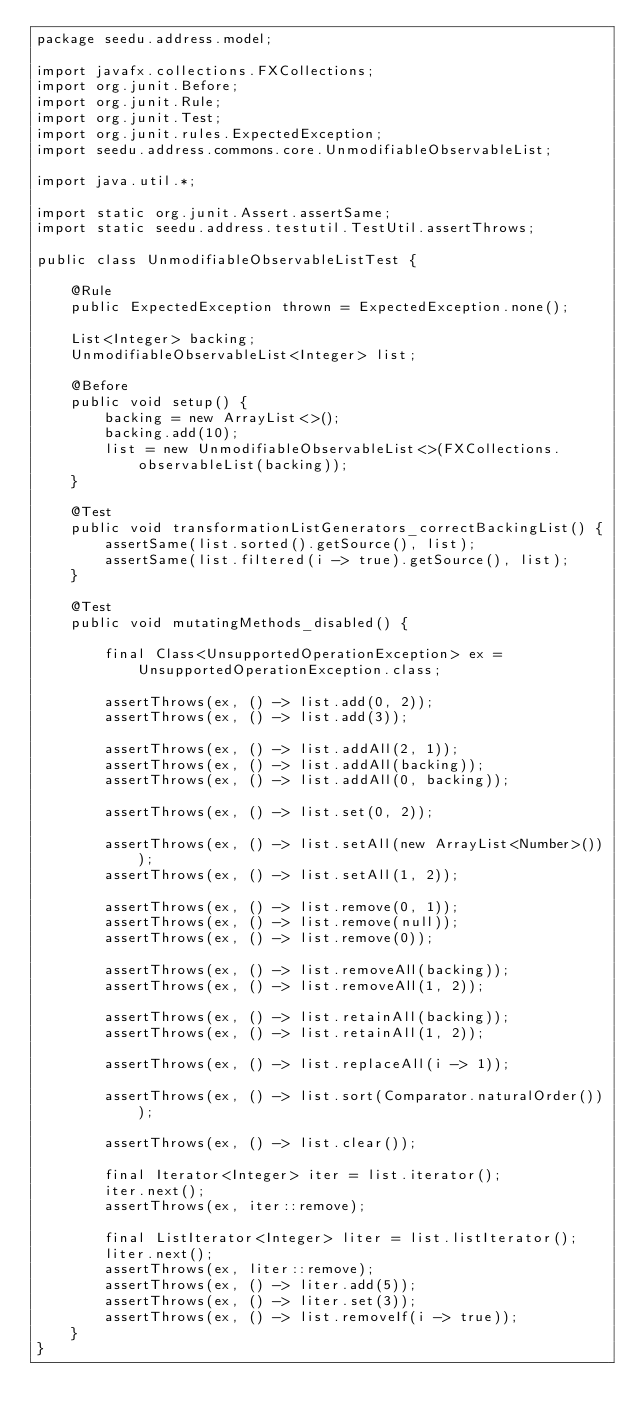<code> <loc_0><loc_0><loc_500><loc_500><_Java_>package seedu.address.model;

import javafx.collections.FXCollections;
import org.junit.Before;
import org.junit.Rule;
import org.junit.Test;
import org.junit.rules.ExpectedException;
import seedu.address.commons.core.UnmodifiableObservableList;

import java.util.*;

import static org.junit.Assert.assertSame;
import static seedu.address.testutil.TestUtil.assertThrows;

public class UnmodifiableObservableListTest {

    @Rule
    public ExpectedException thrown = ExpectedException.none();

    List<Integer> backing;
    UnmodifiableObservableList<Integer> list;

    @Before
    public void setup() {
        backing = new ArrayList<>();
        backing.add(10);
        list = new UnmodifiableObservableList<>(FXCollections.observableList(backing));
    }

    @Test
    public void transformationListGenerators_correctBackingList() {
        assertSame(list.sorted().getSource(), list);
        assertSame(list.filtered(i -> true).getSource(), list);
    }

    @Test
    public void mutatingMethods_disabled() {

        final Class<UnsupportedOperationException> ex = UnsupportedOperationException.class;

        assertThrows(ex, () -> list.add(0, 2));
        assertThrows(ex, () -> list.add(3));

        assertThrows(ex, () -> list.addAll(2, 1));
        assertThrows(ex, () -> list.addAll(backing));
        assertThrows(ex, () -> list.addAll(0, backing));

        assertThrows(ex, () -> list.set(0, 2));

        assertThrows(ex, () -> list.setAll(new ArrayList<Number>()));
        assertThrows(ex, () -> list.setAll(1, 2));

        assertThrows(ex, () -> list.remove(0, 1));
        assertThrows(ex, () -> list.remove(null));
        assertThrows(ex, () -> list.remove(0));

        assertThrows(ex, () -> list.removeAll(backing));
        assertThrows(ex, () -> list.removeAll(1, 2));

        assertThrows(ex, () -> list.retainAll(backing));
        assertThrows(ex, () -> list.retainAll(1, 2));

        assertThrows(ex, () -> list.replaceAll(i -> 1));

        assertThrows(ex, () -> list.sort(Comparator.naturalOrder()));

        assertThrows(ex, () -> list.clear());

        final Iterator<Integer> iter = list.iterator();
        iter.next();
        assertThrows(ex, iter::remove);

        final ListIterator<Integer> liter = list.listIterator();
        liter.next();
        assertThrows(ex, liter::remove);
        assertThrows(ex, () -> liter.add(5));
        assertThrows(ex, () -> liter.set(3));
        assertThrows(ex, () -> list.removeIf(i -> true));
    }
}
</code> 